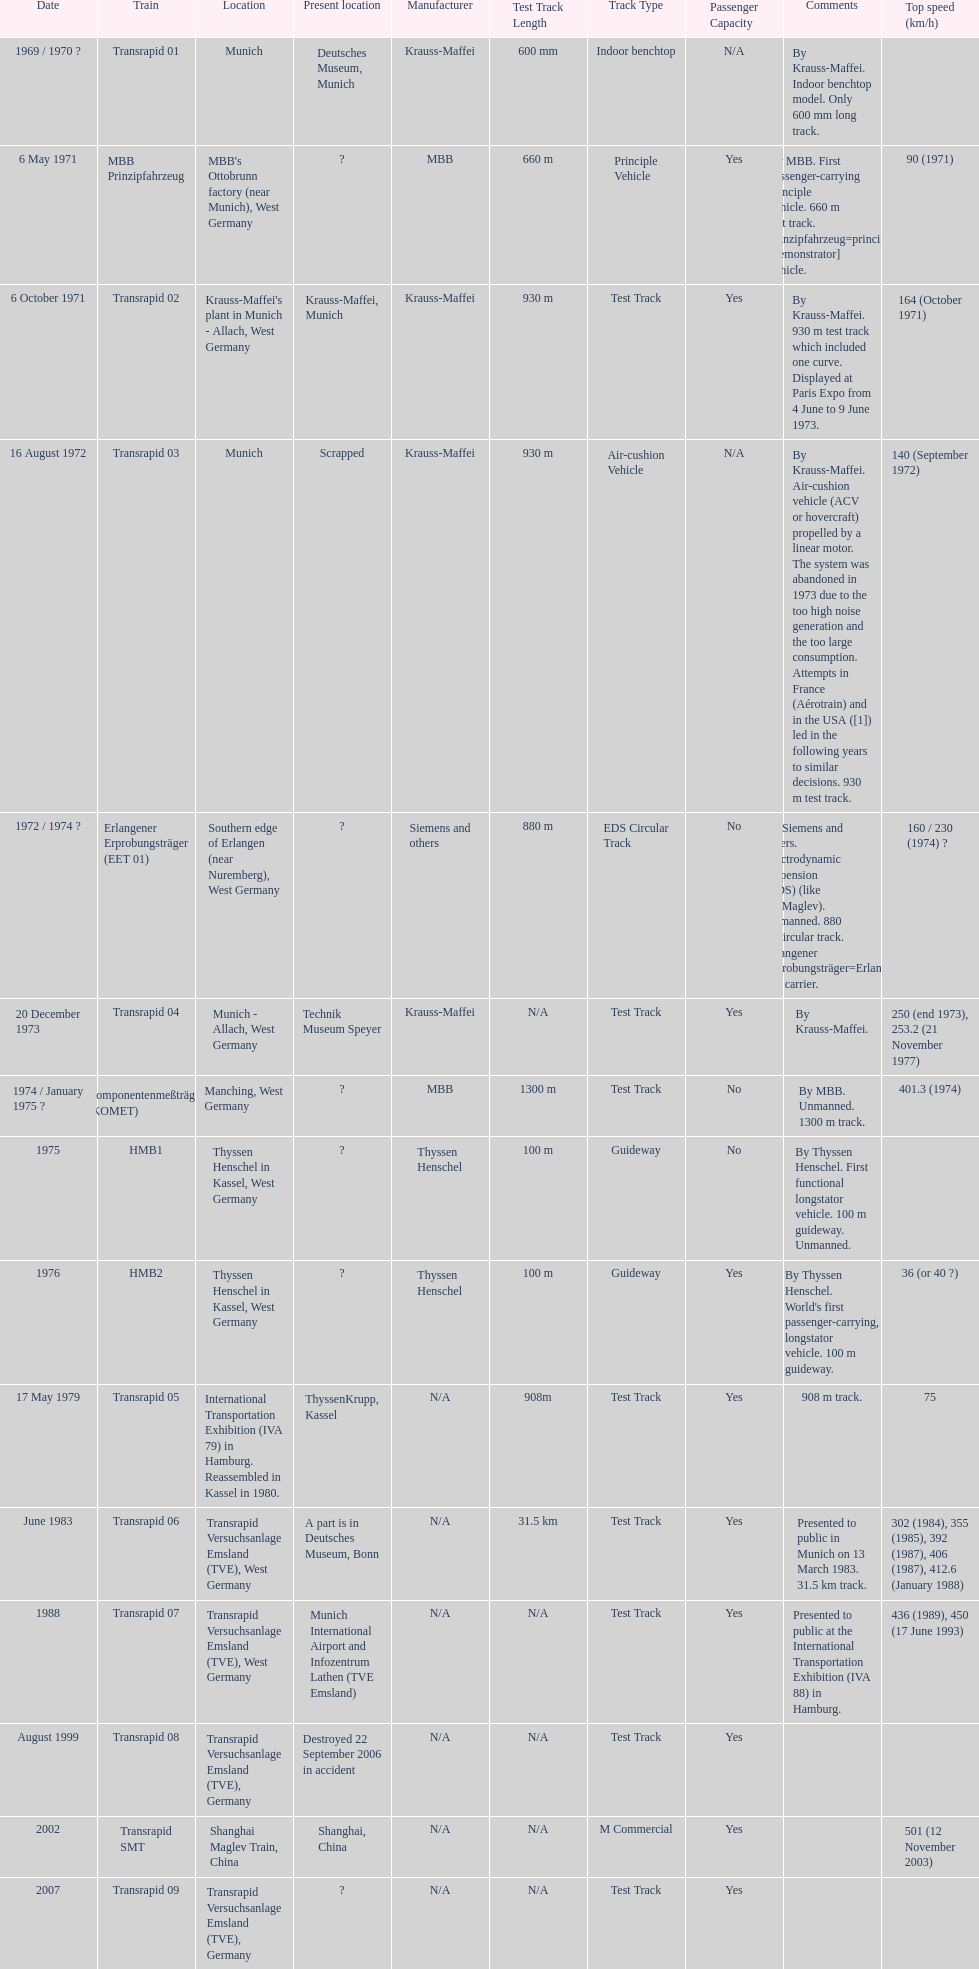What is the number of trains that were either scrapped or destroyed? 2. 